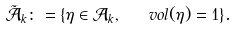Convert formula to latex. <formula><loc_0><loc_0><loc_500><loc_500>\tilde { \mathcal { A } } _ { k } \colon = \{ \eta \in \mathcal { A } _ { k } , \ \ v o l ( \eta ) = 1 \} .</formula> 